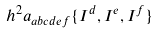Convert formula to latex. <formula><loc_0><loc_0><loc_500><loc_500>h ^ { 2 } a _ { a b c d e f } \{ I ^ { d } , I ^ { e } , I ^ { f } \}</formula> 